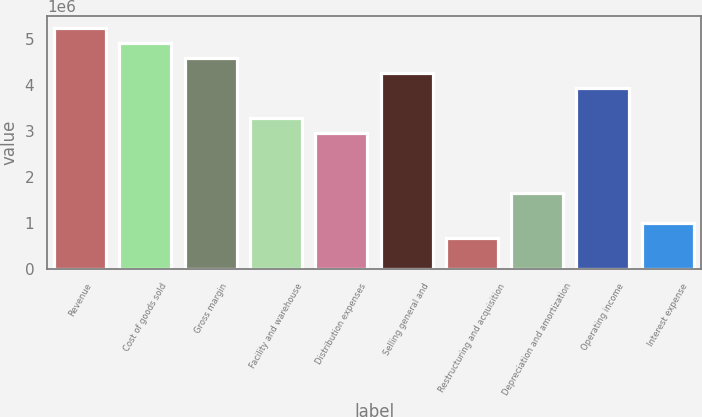Convert chart to OTSL. <chart><loc_0><loc_0><loc_500><loc_500><bar_chart><fcel>Revenue<fcel>Cost of goods sold<fcel>Gross margin<fcel>Facility and warehouse<fcel>Distribution expenses<fcel>Selling general and<fcel>Restructuring and acquisition<fcel>Depreciation and amortization<fcel>Operating income<fcel>Interest expense<nl><fcel>5.23178e+06<fcel>4.90479e+06<fcel>4.57781e+06<fcel>3.26986e+06<fcel>2.94288e+06<fcel>4.25082e+06<fcel>653973<fcel>1.63493e+06<fcel>3.92383e+06<fcel>980959<nl></chart> 